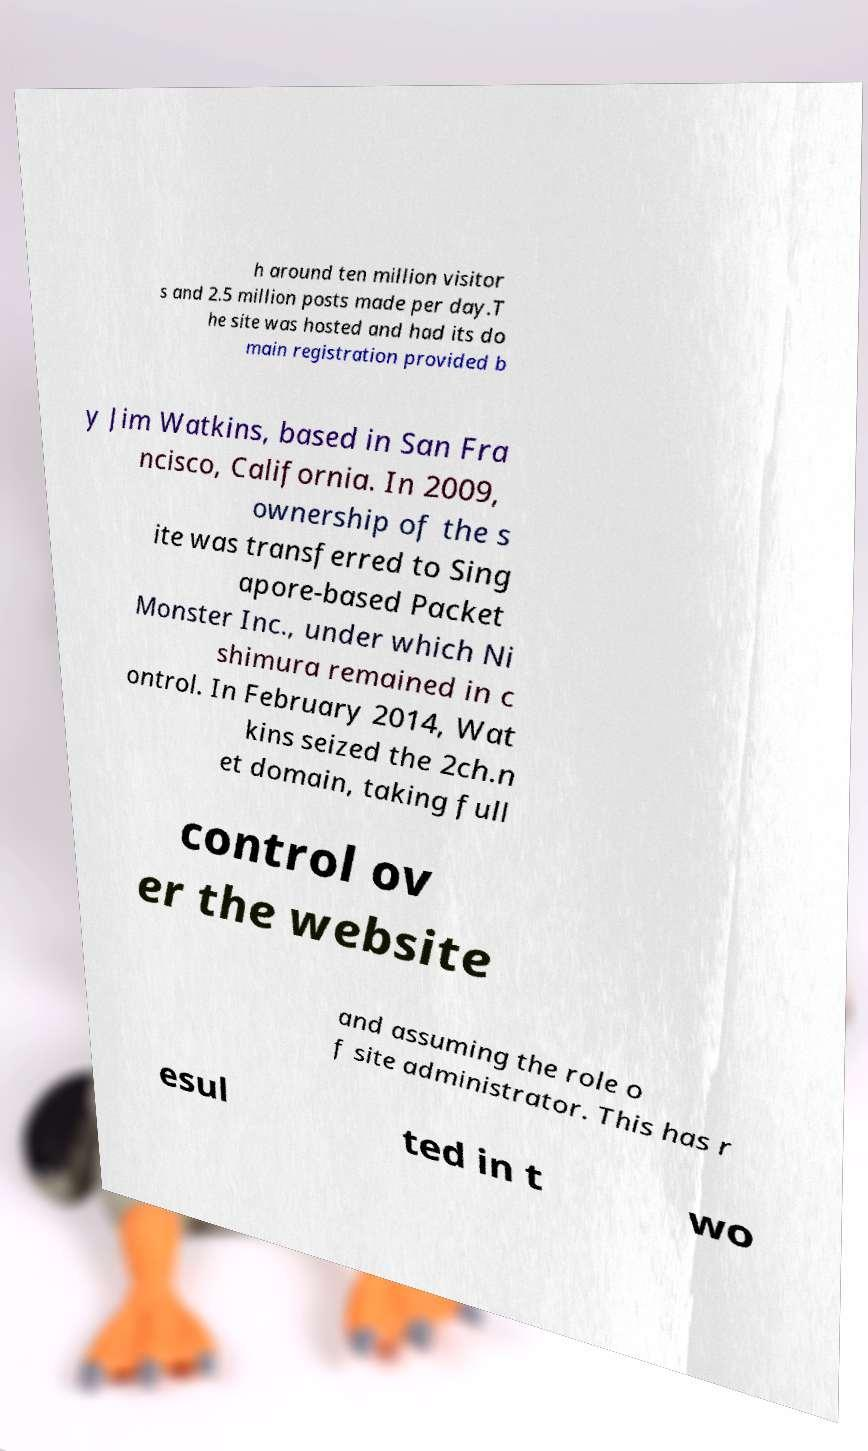Please read and relay the text visible in this image. What does it say? h around ten million visitor s and 2.5 million posts made per day.T he site was hosted and had its do main registration provided b y Jim Watkins, based in San Fra ncisco, California. In 2009, ownership of the s ite was transferred to Sing apore-based Packet Monster Inc., under which Ni shimura remained in c ontrol. In February 2014, Wat kins seized the 2ch.n et domain, taking full control ov er the website and assuming the role o f site administrator. This has r esul ted in t wo 